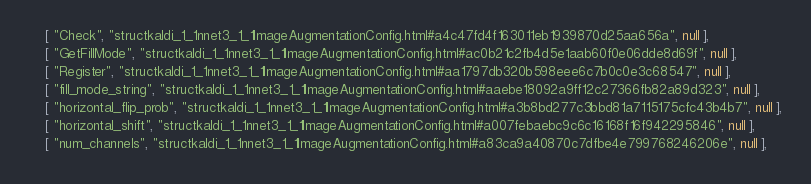<code> <loc_0><loc_0><loc_500><loc_500><_JavaScript_>    [ "Check", "structkaldi_1_1nnet3_1_1ImageAugmentationConfig.html#a4c47fd4f163011eb1939870d25aa656a", null ],
    [ "GetFillMode", "structkaldi_1_1nnet3_1_1ImageAugmentationConfig.html#ac0b21c2fb4d5e1aab60f0e06dde8d69f", null ],
    [ "Register", "structkaldi_1_1nnet3_1_1ImageAugmentationConfig.html#aa1797db320b598eee6c7b0c0e3c68547", null ],
    [ "fill_mode_string", "structkaldi_1_1nnet3_1_1ImageAugmentationConfig.html#aaebe18092a9ff12c27366fb82a89d323", null ],
    [ "horizontal_flip_prob", "structkaldi_1_1nnet3_1_1ImageAugmentationConfig.html#a3b8bd277c3bbd81a7115175cfc43b4b7", null ],
    [ "horizontal_shift", "structkaldi_1_1nnet3_1_1ImageAugmentationConfig.html#a007febaebc9c6c16168f16f942295846", null ],
    [ "num_channels", "structkaldi_1_1nnet3_1_1ImageAugmentationConfig.html#a83ca9a40870c7dfbe4e799768246206e", null ],</code> 